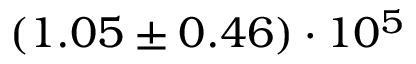<formula> <loc_0><loc_0><loc_500><loc_500>( 1 . 0 5 \pm 0 . 4 6 ) \cdot 1 0 ^ { 5 }</formula> 